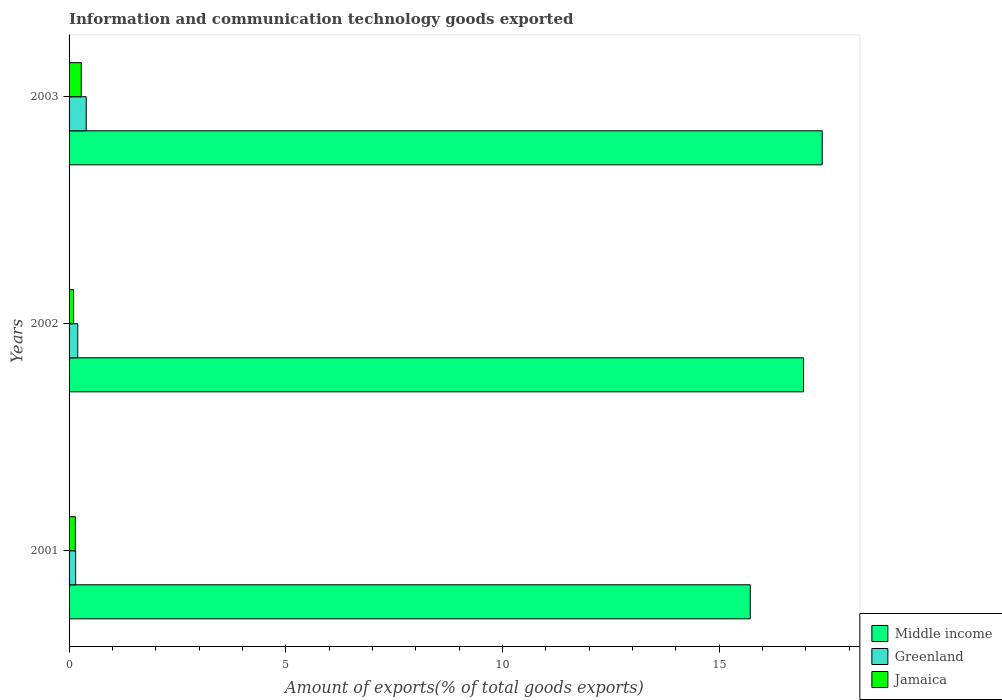How many different coloured bars are there?
Keep it short and to the point. 3. How many groups of bars are there?
Offer a terse response. 3. Are the number of bars on each tick of the Y-axis equal?
Ensure brevity in your answer.  Yes. What is the label of the 3rd group of bars from the top?
Provide a succinct answer. 2001. In how many cases, is the number of bars for a given year not equal to the number of legend labels?
Your answer should be very brief. 0. What is the amount of goods exported in Middle income in 2002?
Offer a terse response. 16.94. Across all years, what is the maximum amount of goods exported in Jamaica?
Offer a terse response. 0.28. Across all years, what is the minimum amount of goods exported in Jamaica?
Give a very brief answer. 0.11. In which year was the amount of goods exported in Greenland maximum?
Keep it short and to the point. 2003. What is the total amount of goods exported in Jamaica in the graph?
Give a very brief answer. 0.53. What is the difference between the amount of goods exported in Middle income in 2001 and that in 2002?
Your response must be concise. -1.23. What is the difference between the amount of goods exported in Greenland in 2001 and the amount of goods exported in Middle income in 2003?
Your answer should be compact. -17.22. What is the average amount of goods exported in Jamaica per year?
Offer a very short reply. 0.18. In the year 2002, what is the difference between the amount of goods exported in Jamaica and amount of goods exported in Middle income?
Ensure brevity in your answer.  -16.84. What is the ratio of the amount of goods exported in Middle income in 2001 to that in 2002?
Keep it short and to the point. 0.93. What is the difference between the highest and the second highest amount of goods exported in Jamaica?
Ensure brevity in your answer.  0.14. What is the difference between the highest and the lowest amount of goods exported in Jamaica?
Your answer should be compact. 0.18. Is the sum of the amount of goods exported in Greenland in 2001 and 2002 greater than the maximum amount of goods exported in Jamaica across all years?
Provide a succinct answer. Yes. What does the 1st bar from the top in 2001 represents?
Ensure brevity in your answer.  Jamaica. What does the 3rd bar from the bottom in 2002 represents?
Provide a succinct answer. Jamaica. Is it the case that in every year, the sum of the amount of goods exported in Jamaica and amount of goods exported in Greenland is greater than the amount of goods exported in Middle income?
Ensure brevity in your answer.  No. How many bars are there?
Your answer should be very brief. 9. Are all the bars in the graph horizontal?
Your answer should be compact. Yes. Where does the legend appear in the graph?
Provide a short and direct response. Bottom right. How many legend labels are there?
Offer a terse response. 3. How are the legend labels stacked?
Ensure brevity in your answer.  Vertical. What is the title of the graph?
Give a very brief answer. Information and communication technology goods exported. What is the label or title of the X-axis?
Your answer should be compact. Amount of exports(% of total goods exports). What is the label or title of the Y-axis?
Your answer should be compact. Years. What is the Amount of exports(% of total goods exports) in Middle income in 2001?
Keep it short and to the point. 15.72. What is the Amount of exports(% of total goods exports) in Greenland in 2001?
Ensure brevity in your answer.  0.15. What is the Amount of exports(% of total goods exports) of Jamaica in 2001?
Provide a short and direct response. 0.15. What is the Amount of exports(% of total goods exports) in Middle income in 2002?
Offer a terse response. 16.94. What is the Amount of exports(% of total goods exports) of Greenland in 2002?
Offer a very short reply. 0.2. What is the Amount of exports(% of total goods exports) in Jamaica in 2002?
Your answer should be very brief. 0.11. What is the Amount of exports(% of total goods exports) in Middle income in 2003?
Your response must be concise. 17.37. What is the Amount of exports(% of total goods exports) in Greenland in 2003?
Provide a short and direct response. 0.4. What is the Amount of exports(% of total goods exports) of Jamaica in 2003?
Give a very brief answer. 0.28. Across all years, what is the maximum Amount of exports(% of total goods exports) in Middle income?
Provide a short and direct response. 17.37. Across all years, what is the maximum Amount of exports(% of total goods exports) in Greenland?
Your answer should be very brief. 0.4. Across all years, what is the maximum Amount of exports(% of total goods exports) in Jamaica?
Provide a short and direct response. 0.28. Across all years, what is the minimum Amount of exports(% of total goods exports) in Middle income?
Offer a terse response. 15.72. Across all years, what is the minimum Amount of exports(% of total goods exports) of Greenland?
Make the answer very short. 0.15. Across all years, what is the minimum Amount of exports(% of total goods exports) of Jamaica?
Offer a terse response. 0.11. What is the total Amount of exports(% of total goods exports) of Middle income in the graph?
Your answer should be compact. 50.03. What is the total Amount of exports(% of total goods exports) of Greenland in the graph?
Your answer should be very brief. 0.75. What is the total Amount of exports(% of total goods exports) of Jamaica in the graph?
Provide a succinct answer. 0.53. What is the difference between the Amount of exports(% of total goods exports) of Middle income in 2001 and that in 2002?
Your answer should be very brief. -1.23. What is the difference between the Amount of exports(% of total goods exports) in Greenland in 2001 and that in 2002?
Provide a short and direct response. -0.05. What is the difference between the Amount of exports(% of total goods exports) in Jamaica in 2001 and that in 2002?
Your response must be concise. 0.04. What is the difference between the Amount of exports(% of total goods exports) of Middle income in 2001 and that in 2003?
Give a very brief answer. -1.66. What is the difference between the Amount of exports(% of total goods exports) in Greenland in 2001 and that in 2003?
Offer a very short reply. -0.24. What is the difference between the Amount of exports(% of total goods exports) in Jamaica in 2001 and that in 2003?
Keep it short and to the point. -0.14. What is the difference between the Amount of exports(% of total goods exports) in Middle income in 2002 and that in 2003?
Give a very brief answer. -0.43. What is the difference between the Amount of exports(% of total goods exports) in Greenland in 2002 and that in 2003?
Your answer should be very brief. -0.2. What is the difference between the Amount of exports(% of total goods exports) in Jamaica in 2002 and that in 2003?
Provide a succinct answer. -0.18. What is the difference between the Amount of exports(% of total goods exports) in Middle income in 2001 and the Amount of exports(% of total goods exports) in Greenland in 2002?
Offer a very short reply. 15.51. What is the difference between the Amount of exports(% of total goods exports) in Middle income in 2001 and the Amount of exports(% of total goods exports) in Jamaica in 2002?
Your answer should be very brief. 15.61. What is the difference between the Amount of exports(% of total goods exports) of Greenland in 2001 and the Amount of exports(% of total goods exports) of Jamaica in 2002?
Your answer should be compact. 0.05. What is the difference between the Amount of exports(% of total goods exports) of Middle income in 2001 and the Amount of exports(% of total goods exports) of Greenland in 2003?
Give a very brief answer. 15.32. What is the difference between the Amount of exports(% of total goods exports) in Middle income in 2001 and the Amount of exports(% of total goods exports) in Jamaica in 2003?
Give a very brief answer. 15.43. What is the difference between the Amount of exports(% of total goods exports) in Greenland in 2001 and the Amount of exports(% of total goods exports) in Jamaica in 2003?
Keep it short and to the point. -0.13. What is the difference between the Amount of exports(% of total goods exports) of Middle income in 2002 and the Amount of exports(% of total goods exports) of Greenland in 2003?
Your response must be concise. 16.55. What is the difference between the Amount of exports(% of total goods exports) in Middle income in 2002 and the Amount of exports(% of total goods exports) in Jamaica in 2003?
Keep it short and to the point. 16.66. What is the difference between the Amount of exports(% of total goods exports) of Greenland in 2002 and the Amount of exports(% of total goods exports) of Jamaica in 2003?
Give a very brief answer. -0.08. What is the average Amount of exports(% of total goods exports) of Middle income per year?
Offer a very short reply. 16.68. What is the average Amount of exports(% of total goods exports) in Greenland per year?
Offer a terse response. 0.25. What is the average Amount of exports(% of total goods exports) of Jamaica per year?
Ensure brevity in your answer.  0.18. In the year 2001, what is the difference between the Amount of exports(% of total goods exports) of Middle income and Amount of exports(% of total goods exports) of Greenland?
Provide a short and direct response. 15.56. In the year 2001, what is the difference between the Amount of exports(% of total goods exports) in Middle income and Amount of exports(% of total goods exports) in Jamaica?
Provide a succinct answer. 15.57. In the year 2001, what is the difference between the Amount of exports(% of total goods exports) in Greenland and Amount of exports(% of total goods exports) in Jamaica?
Offer a terse response. 0.01. In the year 2002, what is the difference between the Amount of exports(% of total goods exports) of Middle income and Amount of exports(% of total goods exports) of Greenland?
Provide a succinct answer. 16.74. In the year 2002, what is the difference between the Amount of exports(% of total goods exports) in Middle income and Amount of exports(% of total goods exports) in Jamaica?
Provide a succinct answer. 16.84. In the year 2002, what is the difference between the Amount of exports(% of total goods exports) of Greenland and Amount of exports(% of total goods exports) of Jamaica?
Offer a very short reply. 0.1. In the year 2003, what is the difference between the Amount of exports(% of total goods exports) of Middle income and Amount of exports(% of total goods exports) of Greenland?
Provide a succinct answer. 16.98. In the year 2003, what is the difference between the Amount of exports(% of total goods exports) of Middle income and Amount of exports(% of total goods exports) of Jamaica?
Your answer should be very brief. 17.09. In the year 2003, what is the difference between the Amount of exports(% of total goods exports) in Greenland and Amount of exports(% of total goods exports) in Jamaica?
Offer a terse response. 0.11. What is the ratio of the Amount of exports(% of total goods exports) in Middle income in 2001 to that in 2002?
Offer a terse response. 0.93. What is the ratio of the Amount of exports(% of total goods exports) in Greenland in 2001 to that in 2002?
Keep it short and to the point. 0.76. What is the ratio of the Amount of exports(% of total goods exports) in Jamaica in 2001 to that in 2002?
Make the answer very short. 1.38. What is the ratio of the Amount of exports(% of total goods exports) of Middle income in 2001 to that in 2003?
Your response must be concise. 0.9. What is the ratio of the Amount of exports(% of total goods exports) in Greenland in 2001 to that in 2003?
Keep it short and to the point. 0.38. What is the ratio of the Amount of exports(% of total goods exports) of Jamaica in 2001 to that in 2003?
Give a very brief answer. 0.52. What is the ratio of the Amount of exports(% of total goods exports) in Middle income in 2002 to that in 2003?
Give a very brief answer. 0.98. What is the ratio of the Amount of exports(% of total goods exports) in Greenland in 2002 to that in 2003?
Provide a succinct answer. 0.51. What is the ratio of the Amount of exports(% of total goods exports) of Jamaica in 2002 to that in 2003?
Provide a succinct answer. 0.37. What is the difference between the highest and the second highest Amount of exports(% of total goods exports) in Middle income?
Ensure brevity in your answer.  0.43. What is the difference between the highest and the second highest Amount of exports(% of total goods exports) in Greenland?
Keep it short and to the point. 0.2. What is the difference between the highest and the second highest Amount of exports(% of total goods exports) in Jamaica?
Your answer should be compact. 0.14. What is the difference between the highest and the lowest Amount of exports(% of total goods exports) in Middle income?
Your answer should be very brief. 1.66. What is the difference between the highest and the lowest Amount of exports(% of total goods exports) of Greenland?
Make the answer very short. 0.24. What is the difference between the highest and the lowest Amount of exports(% of total goods exports) in Jamaica?
Your answer should be very brief. 0.18. 